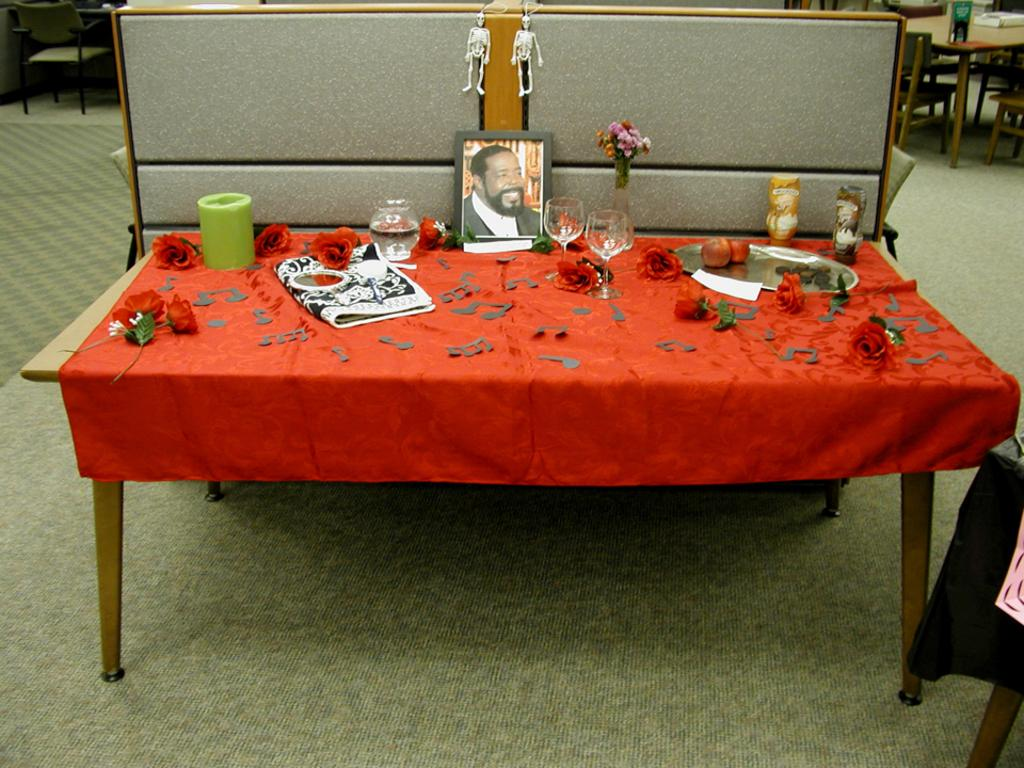What is the main subject of the image? The main subject of the image is a photo frame of a man. What is the photo frame placed on? The photo frame is placed on a red color table cloth. What can be seen in the background of the image? There are tables and chairs in the backdrop of the image. What type of cap is the man wearing in the photo frame? There is no cap visible on the man in the photo frame, as the image only shows the photo frame itself and not the contents of the frame. 